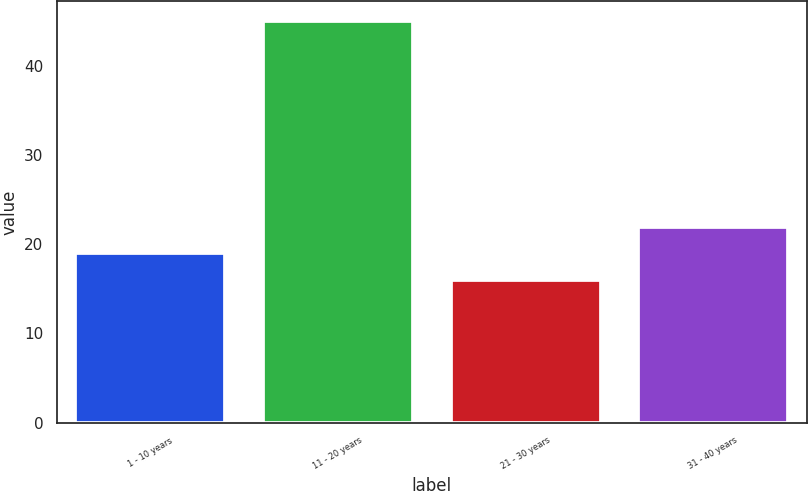Convert chart. <chart><loc_0><loc_0><loc_500><loc_500><bar_chart><fcel>1 - 10 years<fcel>11 - 20 years<fcel>21 - 30 years<fcel>31 - 40 years<nl><fcel>19<fcel>45<fcel>16<fcel>21.9<nl></chart> 